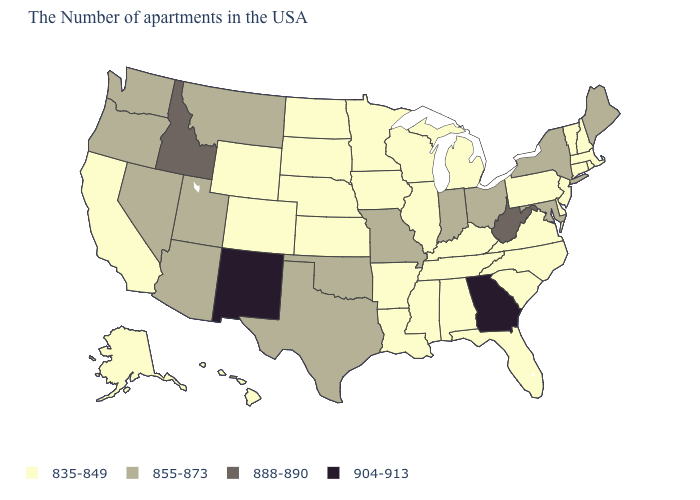Does Montana have the same value as California?
Short answer required. No. Does Massachusetts have the same value as Washington?
Give a very brief answer. No. What is the value of Utah?
Quick response, please. 855-873. How many symbols are there in the legend?
Short answer required. 4. What is the value of Arizona?
Be succinct. 855-873. Does Maryland have the same value as Ohio?
Be succinct. Yes. Name the states that have a value in the range 904-913?
Give a very brief answer. Georgia, New Mexico. What is the value of Nevada?
Keep it brief. 855-873. What is the value of Maryland?
Concise answer only. 855-873. What is the value of North Dakota?
Short answer required. 835-849. Does Georgia have the highest value in the USA?
Answer briefly. Yes. What is the lowest value in the USA?
Write a very short answer. 835-849. Among the states that border Wyoming , which have the lowest value?
Keep it brief. Nebraska, South Dakota, Colorado. Does Maine have the lowest value in the Northeast?
Give a very brief answer. No. Does the first symbol in the legend represent the smallest category?
Be succinct. Yes. 